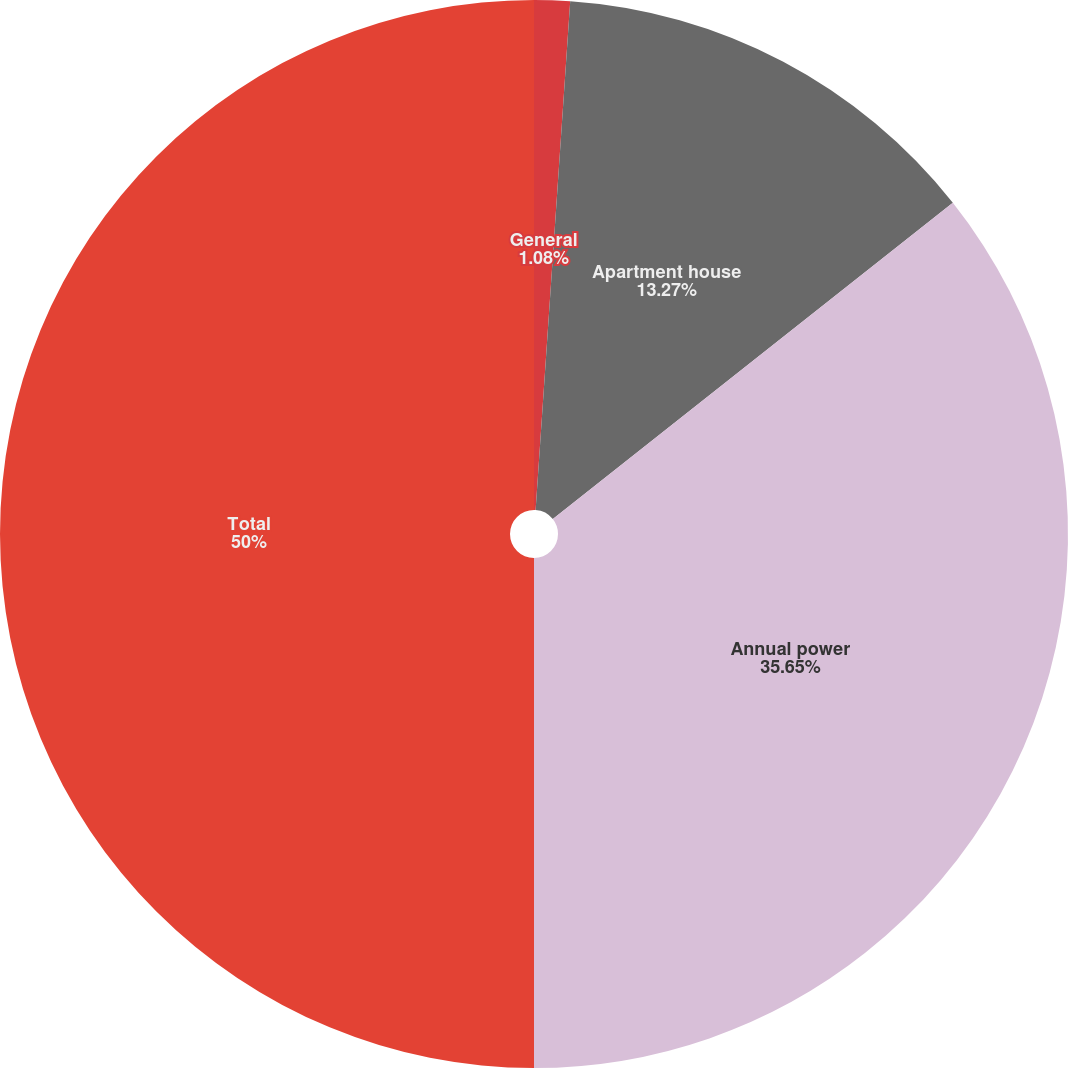Convert chart. <chart><loc_0><loc_0><loc_500><loc_500><pie_chart><fcel>General<fcel>Apartment house<fcel>Annual power<fcel>Total<nl><fcel>1.08%<fcel>13.27%<fcel>35.65%<fcel>50.0%<nl></chart> 